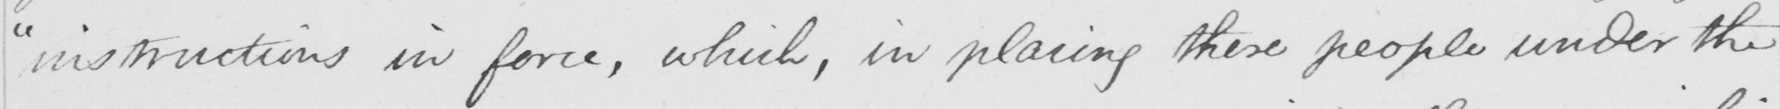What is written in this line of handwriting? " instructions in force , which , in placing these people under the 